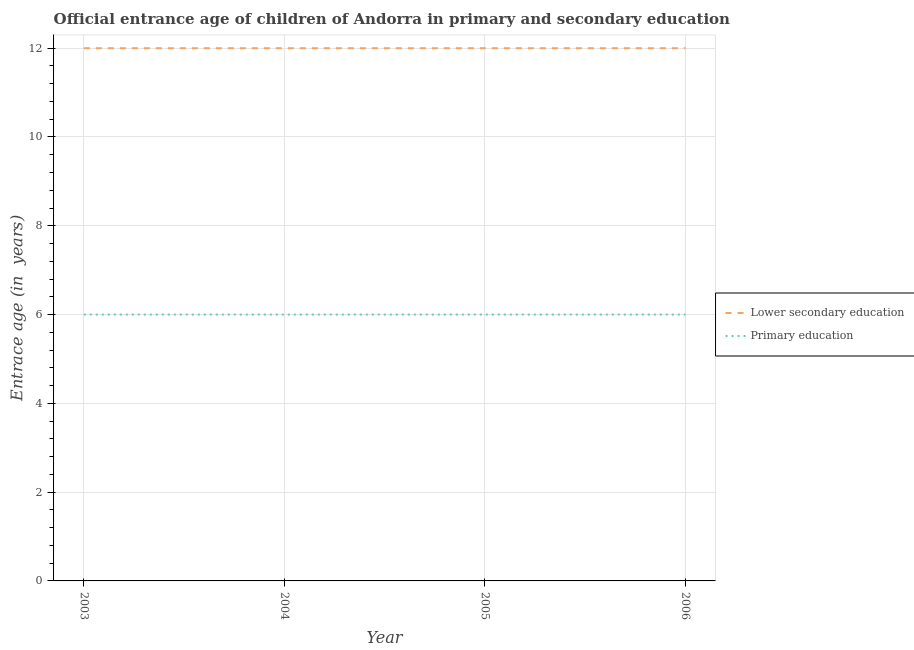How many different coloured lines are there?
Your answer should be very brief. 2. Is the number of lines equal to the number of legend labels?
Offer a very short reply. Yes. What is the entrance age of children in lower secondary education in 2003?
Offer a terse response. 12. Across all years, what is the maximum entrance age of children in lower secondary education?
Make the answer very short. 12. Across all years, what is the minimum entrance age of chiildren in primary education?
Your answer should be very brief. 6. In which year was the entrance age of chiildren in primary education maximum?
Provide a succinct answer. 2003. In which year was the entrance age of children in lower secondary education minimum?
Provide a short and direct response. 2003. What is the total entrance age of chiildren in primary education in the graph?
Keep it short and to the point. 24. What is the difference between the entrance age of children in lower secondary education in 2005 and that in 2006?
Make the answer very short. 0. What is the difference between the entrance age of children in lower secondary education in 2004 and the entrance age of chiildren in primary education in 2003?
Your answer should be compact. 6. In how many years, is the entrance age of children in lower secondary education greater than 3.2 years?
Provide a succinct answer. 4. Is the difference between the entrance age of children in lower secondary education in 2003 and 2006 greater than the difference between the entrance age of chiildren in primary education in 2003 and 2006?
Make the answer very short. No. What is the difference between the highest and the lowest entrance age of children in lower secondary education?
Offer a terse response. 0. In how many years, is the entrance age of children in lower secondary education greater than the average entrance age of children in lower secondary education taken over all years?
Ensure brevity in your answer.  0. Is the entrance age of chiildren in primary education strictly less than the entrance age of children in lower secondary education over the years?
Keep it short and to the point. Yes. How many lines are there?
Offer a very short reply. 2. How many years are there in the graph?
Your answer should be compact. 4. Does the graph contain any zero values?
Make the answer very short. No. Where does the legend appear in the graph?
Keep it short and to the point. Center right. How are the legend labels stacked?
Your response must be concise. Vertical. What is the title of the graph?
Ensure brevity in your answer.  Official entrance age of children of Andorra in primary and secondary education. What is the label or title of the X-axis?
Your answer should be compact. Year. What is the label or title of the Y-axis?
Give a very brief answer. Entrace age (in  years). What is the Entrace age (in  years) in Lower secondary education in 2005?
Offer a very short reply. 12. What is the Entrace age (in  years) in Primary education in 2005?
Make the answer very short. 6. What is the Entrace age (in  years) in Primary education in 2006?
Your answer should be very brief. 6. Across all years, what is the maximum Entrace age (in  years) of Lower secondary education?
Ensure brevity in your answer.  12. Across all years, what is the maximum Entrace age (in  years) in Primary education?
Ensure brevity in your answer.  6. Across all years, what is the minimum Entrace age (in  years) of Primary education?
Make the answer very short. 6. What is the difference between the Entrace age (in  years) of Lower secondary education in 2003 and that in 2004?
Provide a short and direct response. 0. What is the difference between the Entrace age (in  years) in Primary education in 2003 and that in 2004?
Ensure brevity in your answer.  0. What is the difference between the Entrace age (in  years) of Lower secondary education in 2003 and that in 2005?
Offer a very short reply. 0. What is the difference between the Entrace age (in  years) of Primary education in 2003 and that in 2005?
Your answer should be very brief. 0. What is the difference between the Entrace age (in  years) in Lower secondary education in 2003 and that in 2006?
Your response must be concise. 0. What is the difference between the Entrace age (in  years) in Primary education in 2004 and that in 2005?
Make the answer very short. 0. What is the difference between the Entrace age (in  years) in Lower secondary education in 2003 and the Entrace age (in  years) in Primary education in 2004?
Your answer should be very brief. 6. What is the difference between the Entrace age (in  years) of Lower secondary education in 2003 and the Entrace age (in  years) of Primary education in 2006?
Keep it short and to the point. 6. What is the difference between the Entrace age (in  years) in Lower secondary education in 2004 and the Entrace age (in  years) in Primary education in 2005?
Make the answer very short. 6. What is the difference between the Entrace age (in  years) of Lower secondary education in 2005 and the Entrace age (in  years) of Primary education in 2006?
Offer a terse response. 6. What is the average Entrace age (in  years) of Lower secondary education per year?
Your response must be concise. 12. In the year 2004, what is the difference between the Entrace age (in  years) in Lower secondary education and Entrace age (in  years) in Primary education?
Offer a terse response. 6. In the year 2005, what is the difference between the Entrace age (in  years) of Lower secondary education and Entrace age (in  years) of Primary education?
Your answer should be very brief. 6. In the year 2006, what is the difference between the Entrace age (in  years) in Lower secondary education and Entrace age (in  years) in Primary education?
Your answer should be very brief. 6. What is the ratio of the Entrace age (in  years) of Primary education in 2003 to that in 2004?
Provide a succinct answer. 1. What is the ratio of the Entrace age (in  years) in Primary education in 2003 to that in 2005?
Make the answer very short. 1. What is the ratio of the Entrace age (in  years) of Lower secondary education in 2003 to that in 2006?
Your response must be concise. 1. What is the ratio of the Entrace age (in  years) in Primary education in 2004 to that in 2006?
Your answer should be very brief. 1. What is the ratio of the Entrace age (in  years) in Lower secondary education in 2005 to that in 2006?
Your answer should be compact. 1. What is the ratio of the Entrace age (in  years) of Primary education in 2005 to that in 2006?
Ensure brevity in your answer.  1. What is the difference between the highest and the second highest Entrace age (in  years) of Lower secondary education?
Offer a very short reply. 0. 